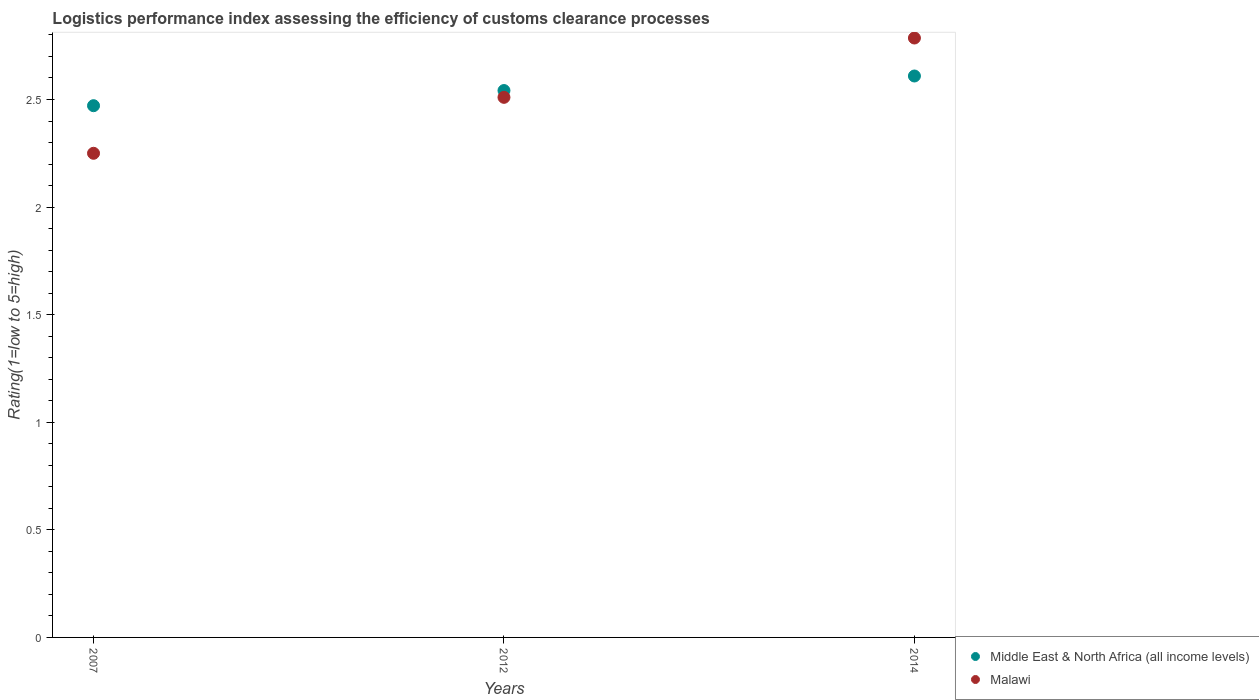How many different coloured dotlines are there?
Keep it short and to the point. 2. What is the Logistic performance index in Malawi in 2007?
Make the answer very short. 2.25. Across all years, what is the maximum Logistic performance index in Malawi?
Make the answer very short. 2.79. Across all years, what is the minimum Logistic performance index in Middle East & North Africa (all income levels)?
Offer a very short reply. 2.47. In which year was the Logistic performance index in Malawi maximum?
Your response must be concise. 2014. In which year was the Logistic performance index in Middle East & North Africa (all income levels) minimum?
Your answer should be very brief. 2007. What is the total Logistic performance index in Middle East & North Africa (all income levels) in the graph?
Offer a very short reply. 7.62. What is the difference between the Logistic performance index in Middle East & North Africa (all income levels) in 2007 and that in 2014?
Make the answer very short. -0.14. What is the difference between the Logistic performance index in Middle East & North Africa (all income levels) in 2014 and the Logistic performance index in Malawi in 2012?
Your response must be concise. 0.1. What is the average Logistic performance index in Middle East & North Africa (all income levels) per year?
Provide a short and direct response. 2.54. In the year 2007, what is the difference between the Logistic performance index in Malawi and Logistic performance index in Middle East & North Africa (all income levels)?
Your answer should be compact. -0.22. What is the ratio of the Logistic performance index in Middle East & North Africa (all income levels) in 2007 to that in 2014?
Provide a short and direct response. 0.95. Is the difference between the Logistic performance index in Malawi in 2012 and 2014 greater than the difference between the Logistic performance index in Middle East & North Africa (all income levels) in 2012 and 2014?
Your response must be concise. No. What is the difference between the highest and the second highest Logistic performance index in Malawi?
Offer a very short reply. 0.28. What is the difference between the highest and the lowest Logistic performance index in Middle East & North Africa (all income levels)?
Ensure brevity in your answer.  0.14. In how many years, is the Logistic performance index in Malawi greater than the average Logistic performance index in Malawi taken over all years?
Give a very brief answer. 1. Is the sum of the Logistic performance index in Malawi in 2012 and 2014 greater than the maximum Logistic performance index in Middle East & North Africa (all income levels) across all years?
Ensure brevity in your answer.  Yes. Does the Logistic performance index in Malawi monotonically increase over the years?
Your response must be concise. Yes. Is the Logistic performance index in Middle East & North Africa (all income levels) strictly greater than the Logistic performance index in Malawi over the years?
Make the answer very short. No. Does the graph contain any zero values?
Provide a succinct answer. No. Where does the legend appear in the graph?
Provide a succinct answer. Bottom right. How are the legend labels stacked?
Your answer should be compact. Vertical. What is the title of the graph?
Your answer should be very brief. Logistics performance index assessing the efficiency of customs clearance processes. What is the label or title of the X-axis?
Ensure brevity in your answer.  Years. What is the label or title of the Y-axis?
Provide a succinct answer. Rating(1=low to 5=high). What is the Rating(1=low to 5=high) in Middle East & North Africa (all income levels) in 2007?
Your response must be concise. 2.47. What is the Rating(1=low to 5=high) of Malawi in 2007?
Provide a short and direct response. 2.25. What is the Rating(1=low to 5=high) in Middle East & North Africa (all income levels) in 2012?
Ensure brevity in your answer.  2.54. What is the Rating(1=low to 5=high) in Malawi in 2012?
Provide a succinct answer. 2.51. What is the Rating(1=low to 5=high) of Middle East & North Africa (all income levels) in 2014?
Give a very brief answer. 2.61. What is the Rating(1=low to 5=high) in Malawi in 2014?
Your response must be concise. 2.79. Across all years, what is the maximum Rating(1=low to 5=high) of Middle East & North Africa (all income levels)?
Ensure brevity in your answer.  2.61. Across all years, what is the maximum Rating(1=low to 5=high) of Malawi?
Keep it short and to the point. 2.79. Across all years, what is the minimum Rating(1=low to 5=high) of Middle East & North Africa (all income levels)?
Provide a succinct answer. 2.47. Across all years, what is the minimum Rating(1=low to 5=high) of Malawi?
Offer a terse response. 2.25. What is the total Rating(1=low to 5=high) in Middle East & North Africa (all income levels) in the graph?
Ensure brevity in your answer.  7.62. What is the total Rating(1=low to 5=high) of Malawi in the graph?
Ensure brevity in your answer.  7.55. What is the difference between the Rating(1=low to 5=high) in Middle East & North Africa (all income levels) in 2007 and that in 2012?
Give a very brief answer. -0.07. What is the difference between the Rating(1=low to 5=high) in Malawi in 2007 and that in 2012?
Provide a short and direct response. -0.26. What is the difference between the Rating(1=low to 5=high) of Middle East & North Africa (all income levels) in 2007 and that in 2014?
Offer a very short reply. -0.14. What is the difference between the Rating(1=low to 5=high) of Malawi in 2007 and that in 2014?
Provide a succinct answer. -0.54. What is the difference between the Rating(1=low to 5=high) of Middle East & North Africa (all income levels) in 2012 and that in 2014?
Keep it short and to the point. -0.07. What is the difference between the Rating(1=low to 5=high) in Malawi in 2012 and that in 2014?
Provide a short and direct response. -0.28. What is the difference between the Rating(1=low to 5=high) of Middle East & North Africa (all income levels) in 2007 and the Rating(1=low to 5=high) of Malawi in 2012?
Your answer should be very brief. -0.04. What is the difference between the Rating(1=low to 5=high) in Middle East & North Africa (all income levels) in 2007 and the Rating(1=low to 5=high) in Malawi in 2014?
Your response must be concise. -0.31. What is the difference between the Rating(1=low to 5=high) in Middle East & North Africa (all income levels) in 2012 and the Rating(1=low to 5=high) in Malawi in 2014?
Make the answer very short. -0.24. What is the average Rating(1=low to 5=high) of Middle East & North Africa (all income levels) per year?
Provide a short and direct response. 2.54. What is the average Rating(1=low to 5=high) in Malawi per year?
Your answer should be very brief. 2.52. In the year 2007, what is the difference between the Rating(1=low to 5=high) in Middle East & North Africa (all income levels) and Rating(1=low to 5=high) in Malawi?
Ensure brevity in your answer.  0.22. In the year 2012, what is the difference between the Rating(1=low to 5=high) in Middle East & North Africa (all income levels) and Rating(1=low to 5=high) in Malawi?
Your response must be concise. 0.03. In the year 2014, what is the difference between the Rating(1=low to 5=high) of Middle East & North Africa (all income levels) and Rating(1=low to 5=high) of Malawi?
Keep it short and to the point. -0.18. What is the ratio of the Rating(1=low to 5=high) of Middle East & North Africa (all income levels) in 2007 to that in 2012?
Your answer should be very brief. 0.97. What is the ratio of the Rating(1=low to 5=high) of Malawi in 2007 to that in 2012?
Provide a succinct answer. 0.9. What is the ratio of the Rating(1=low to 5=high) of Middle East & North Africa (all income levels) in 2007 to that in 2014?
Provide a short and direct response. 0.95. What is the ratio of the Rating(1=low to 5=high) in Malawi in 2007 to that in 2014?
Ensure brevity in your answer.  0.81. What is the ratio of the Rating(1=low to 5=high) of Middle East & North Africa (all income levels) in 2012 to that in 2014?
Your answer should be very brief. 0.97. What is the ratio of the Rating(1=low to 5=high) in Malawi in 2012 to that in 2014?
Offer a very short reply. 0.9. What is the difference between the highest and the second highest Rating(1=low to 5=high) in Middle East & North Africa (all income levels)?
Give a very brief answer. 0.07. What is the difference between the highest and the second highest Rating(1=low to 5=high) of Malawi?
Keep it short and to the point. 0.28. What is the difference between the highest and the lowest Rating(1=low to 5=high) in Middle East & North Africa (all income levels)?
Ensure brevity in your answer.  0.14. What is the difference between the highest and the lowest Rating(1=low to 5=high) in Malawi?
Give a very brief answer. 0.54. 